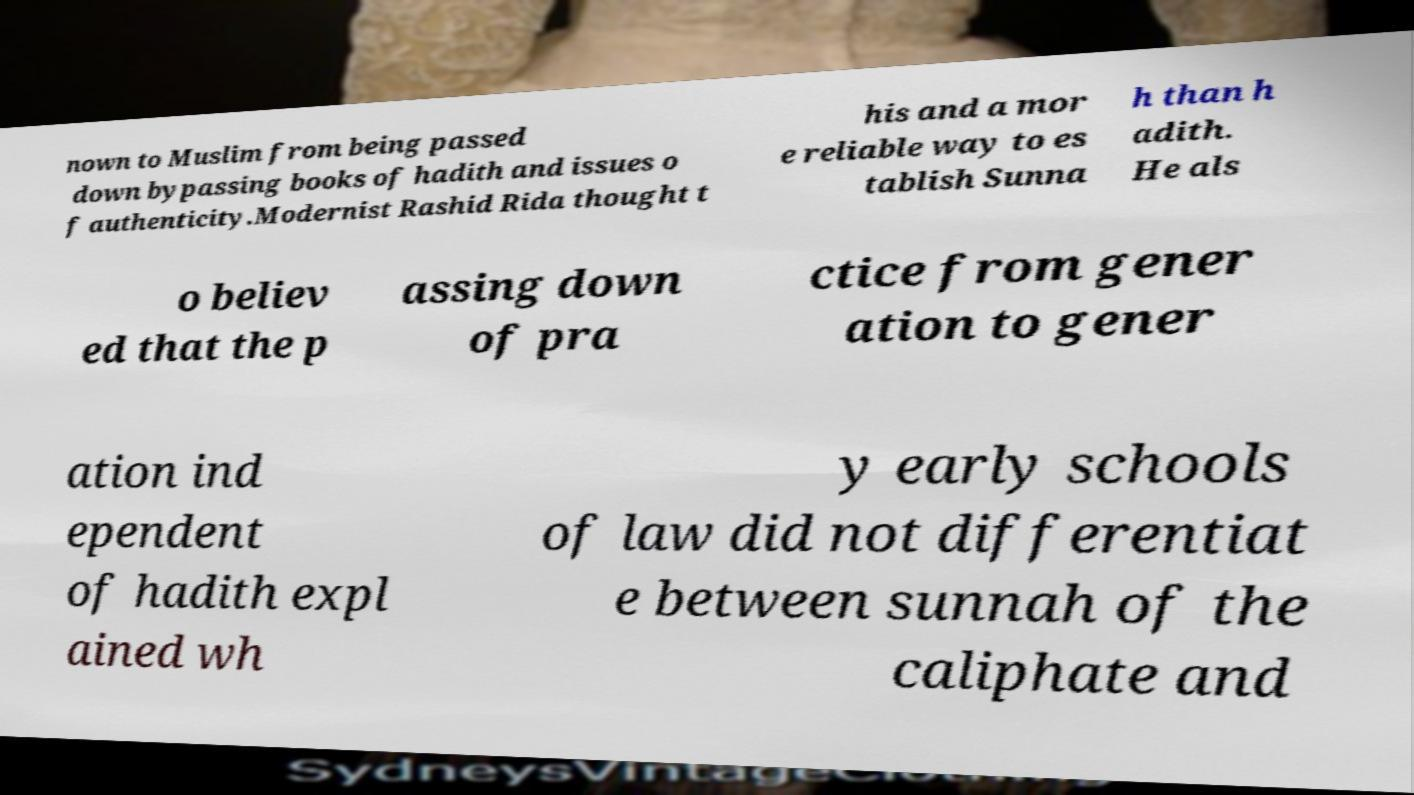For documentation purposes, I need the text within this image transcribed. Could you provide that? nown to Muslim from being passed down bypassing books of hadith and issues o f authenticity.Modernist Rashid Rida thought t his and a mor e reliable way to es tablish Sunna h than h adith. He als o believ ed that the p assing down of pra ctice from gener ation to gener ation ind ependent of hadith expl ained wh y early schools of law did not differentiat e between sunnah of the caliphate and 